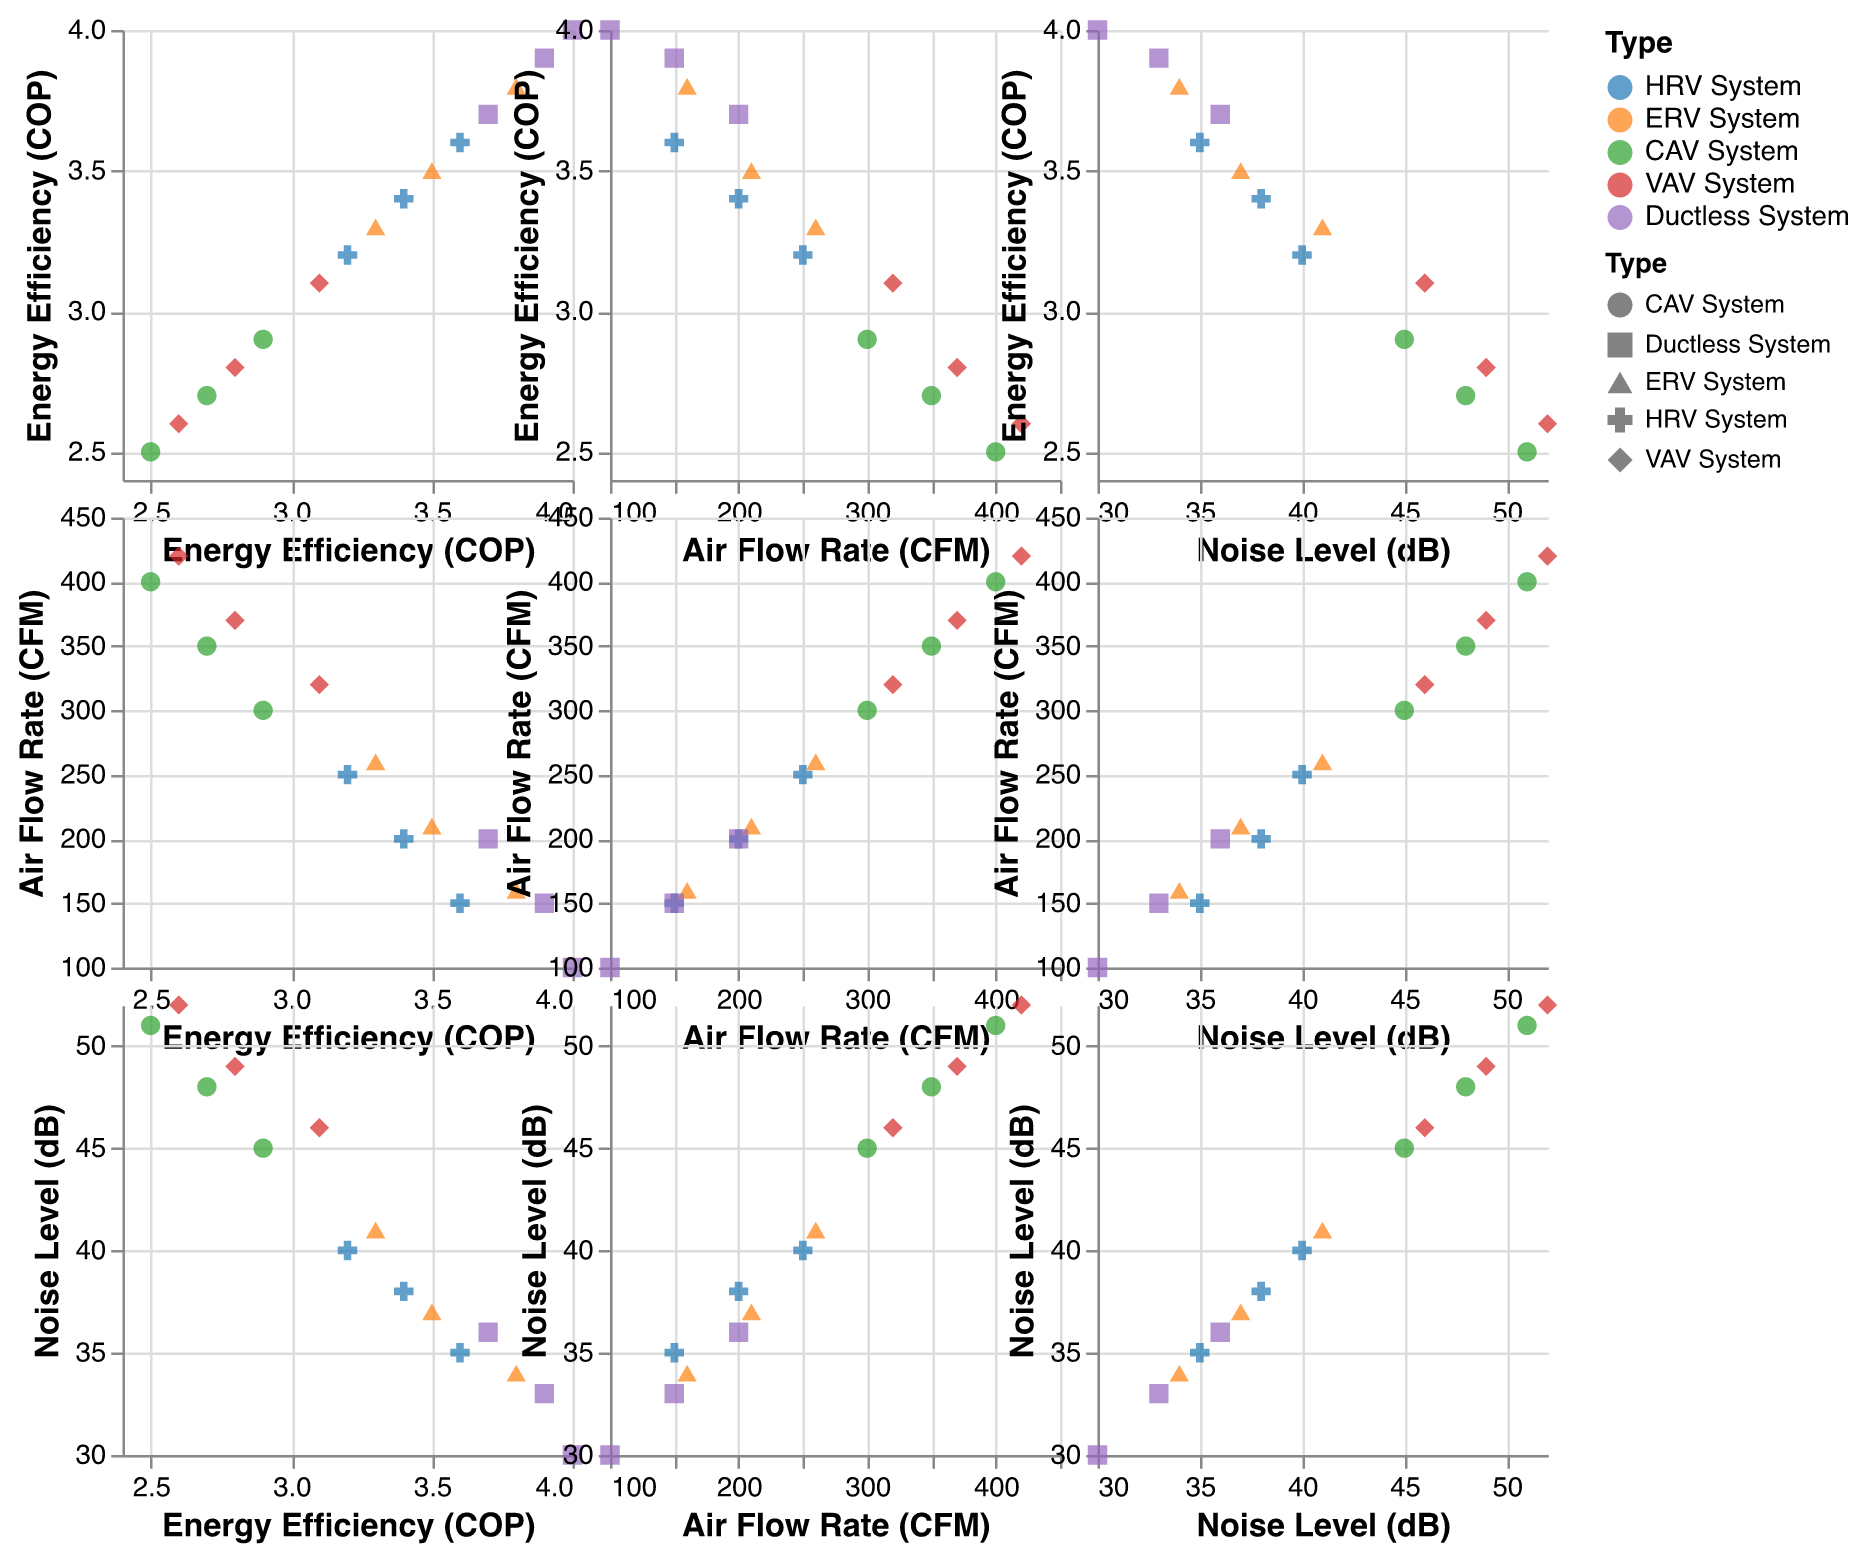How many types of mechanical ventilation systems are represented in the figure? The legend on the right side of the figure displays the distinct types of mechanical ventilation systems, which are color-coded and shaped differently. By counting these unique entries, we find that there are 5 distinct types.
Answer: 5 types Which ventilation system type has the highest energy efficiency (COP)? Observing the points corresponding to the highest values on the Energy Efficiency (COP) scale, we see that the Ductless System has points reaching up to an energy efficiency of 4.0.
Answer: Ductless System What is the trend between Air Flow Rate (CFM) and Noise Level (dB) for CAV System? By looking at the plot of Air Flow Rate versus Noise Level for the CAV System (marked in a specific color and shape), we notice that as the Air Flow Rate increases, the Noise Level also increases.
Answer: Increasing trend Which ventilation system type appears to have the lowest noise levels? By observing the Noise Level (dB) axis and finding the ventilation system types corresponding to the lowest values, Ductless System points are found to be at the lowest noise levels, around 30-36 dB.
Answer: Ductless System Which system type generally has the highest Air Flow Rate (CFM)? From the scatter plot matrix, we can see which system type points consistently occupy the higher values on the Air Flow Rate axis. The CAV System has points extending up to an Air Flow Rate of 400 CFM.
Answer: CAV System What is the relationship between Energy Efficiency (COP) and Noise Level (dB) for VAV System? Observing the points representing VAV System on the plot of Energy Efficiency versus Noise Level, we notice these points indicate that as the Energy Efficiency decreases, the Noise Level increases.
Answer: Inversely proportional How does the Energy Efficiency (COP) of ERV System compare to HRV System? Comparing the points for ERV System and HRV System on the Energy Efficiency axis, we see that ERV System generally has higher energy efficiency values (3.8, 3.5, 3.3) compared to HRV System (3.6, 3.4, 3.2).
Answer: ERV System is higher Which system type shows the most variation in Air Flow Rate? To identify the system type with the most variation, we look at the spread of points along the Air Flow Rate axis for each system. CAV System points cover a wide range from 300 to 400 CFM.
Answer: CAV System What are the typical noise levels for HRV System and how do they compare to other systems? Looking at the Noise Level axis and the HRV System points, HRV System typically has noise levels around 35-40 dB. When comparing to other systems, HRV is generally quieter than CAV and VAV but louder than Ductless and slightly louder than ERV.
Answer: Around 35-40 dB, quieter than CAV and VAV, louder than Ductless, slightly louder than ERV 